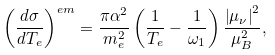Convert formula to latex. <formula><loc_0><loc_0><loc_500><loc_500>\left ( \frac { d \sigma } { d T _ { e } } \right ) ^ { e m } = \frac { \pi \alpha ^ { 2 } } { m _ { e } ^ { 2 } } \left ( \frac { 1 } { T _ { e } } - \frac { 1 } { \omega _ { 1 } } \right ) \frac { \left | \mu _ { \nu } \right | ^ { 2 } } { \mu _ { B } ^ { 2 } } ,</formula> 